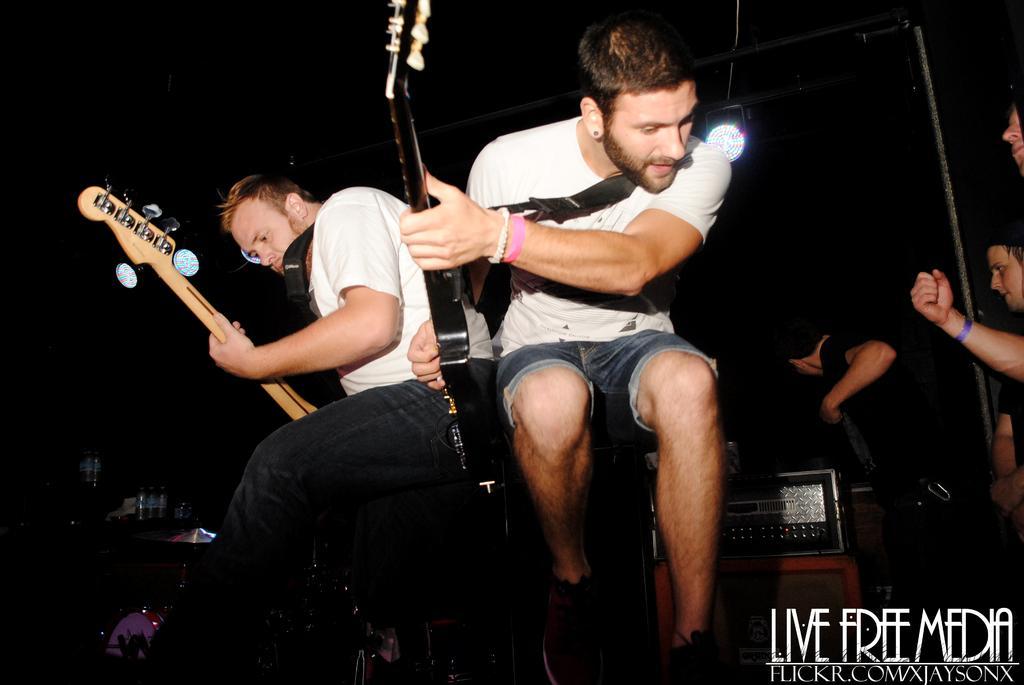How would you summarize this image in a sentence or two? This picture shows a two men playing a guitars in their hands on the stage and there are some people standing on the right side. 